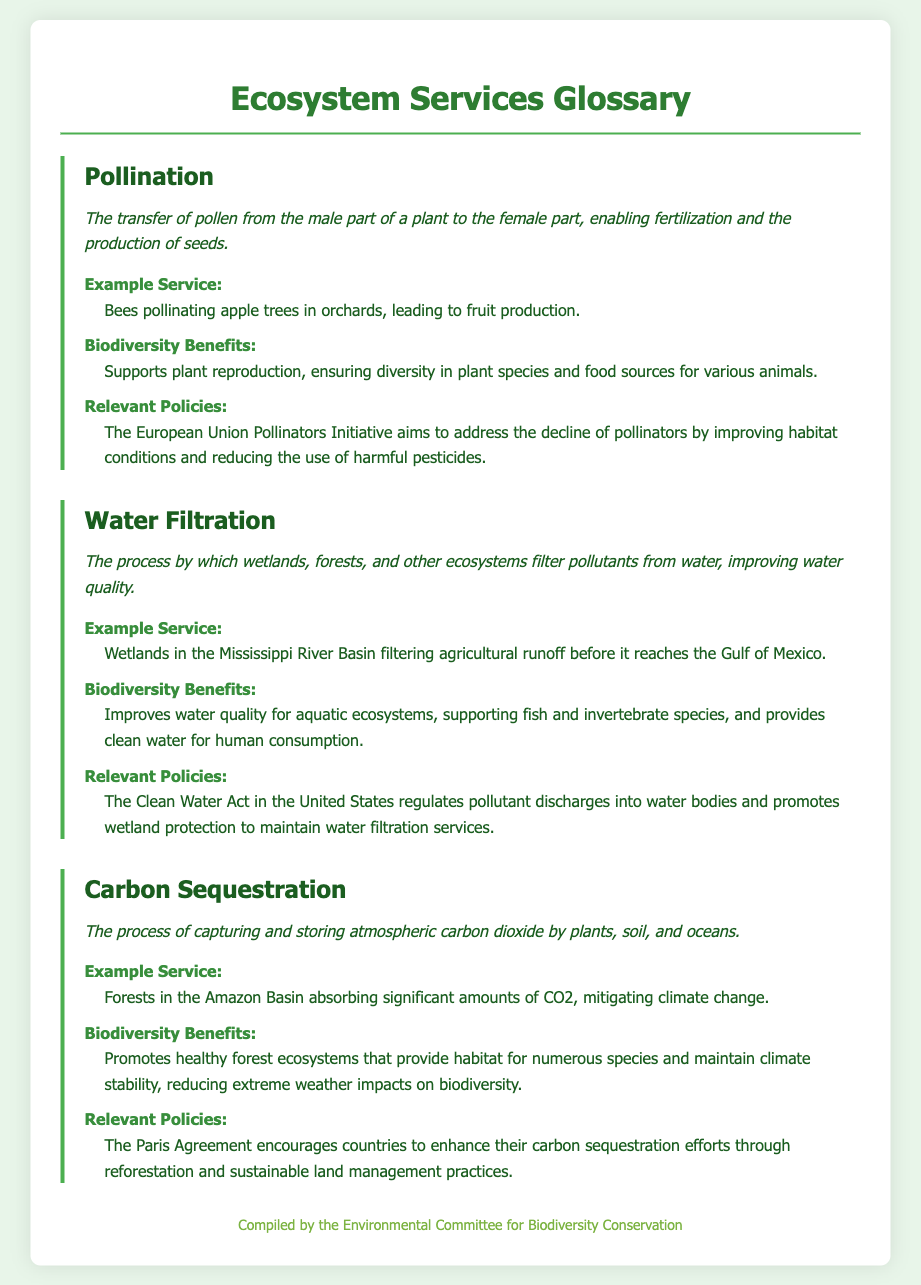What is pollination? Pollination is defined as the transfer of pollen from the male part of a plant to the female part, enabling fertilization and the production of seeds.
Answer: Transfer of pollen Give an example of a service provided by pollination. The example service provided is that bees pollinate apple trees in orchards, leading to fruit production.
Answer: Bees pollinating apple trees What is one biodiversity benefit of water filtration? One biodiversity benefit of water filtration is that it improves water quality for aquatic ecosystems, supporting fish and invertebrate species.
Answer: Improves water quality What relevant policy is associated with carbon sequestration? The policy associated with carbon sequestration is the Paris Agreement, which encourages countries to enhance their carbon sequestration efforts.
Answer: Paris Agreement What is the definition of carbon sequestration? Carbon sequestration is defined as the process of capturing and storing atmospheric carbon dioxide by plants, soil, and oceans.
Answer: Capturing and storing carbon dioxide How do wetlands contribute to water quality? Wetlands contribute to water quality by filtering pollutants from water, which improves water quality.
Answer: Filtering pollutants What is the biodiversity benefit of pollination? The biodiversity benefit of pollination is that it supports plant reproduction, ensuring diversity in plant species and food sources for various animals.
Answer: Supports plant reproduction What service is provided by wetlands in the Mississippi River Basin? The service provided by wetlands in the Mississippi River Basin is filtering agricultural runoff before it reaches the Gulf of Mexico.
Answer: Filtering agricultural runoff What is the sub-heading for biodiversity benefits under carbon sequestration? The sub-heading for biodiversity benefits under carbon sequestration is "Biodiversity Benefits."
Answer: Biodiversity Benefits 